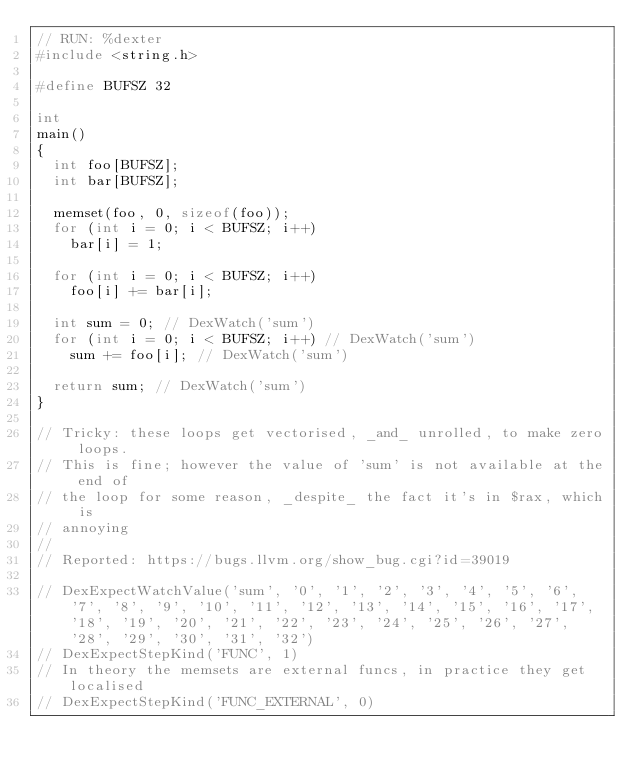<code> <loc_0><loc_0><loc_500><loc_500><_C++_>// RUN: %dexter
#include <string.h>

#define BUFSZ 32

int
main()
{
  int foo[BUFSZ];
  int bar[BUFSZ];

  memset(foo, 0, sizeof(foo));
  for (int i = 0; i < BUFSZ; i++)
    bar[i] = 1;

  for (int i = 0; i < BUFSZ; i++)
    foo[i] += bar[i];

  int sum = 0; // DexWatch('sum')
  for (int i = 0; i < BUFSZ; i++) // DexWatch('sum')
    sum += foo[i]; // DexWatch('sum')

  return sum; // DexWatch('sum')
}

// Tricky: these loops get vectorised, _and_ unrolled, to make zero loops.
// This is fine; however the value of 'sum' is not available at the end of
// the loop for some reason, _despite_ the fact it's in $rax, which is
// annoying
//
// Reported: https://bugs.llvm.org/show_bug.cgi?id=39019

// DexExpectWatchValue('sum', '0', '1', '2', '3', '4', '5', '6', '7', '8', '9', '10', '11', '12', '13', '14', '15', '16', '17', '18', '19', '20', '21', '22', '23', '24', '25', '26', '27', '28', '29', '30', '31', '32')
// DexExpectStepKind('FUNC', 1)
// In theory the memsets are external funcs, in practice they get localised
// DexExpectStepKind('FUNC_EXTERNAL', 0)
</code> 